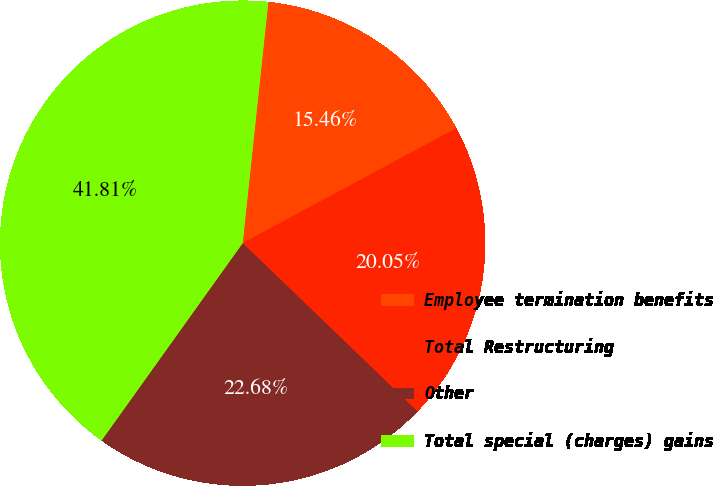Convert chart. <chart><loc_0><loc_0><loc_500><loc_500><pie_chart><fcel>Employee termination benefits<fcel>Total Restructuring<fcel>Other<fcel>Total special (charges) gains<nl><fcel>15.46%<fcel>20.05%<fcel>22.68%<fcel>41.81%<nl></chart> 